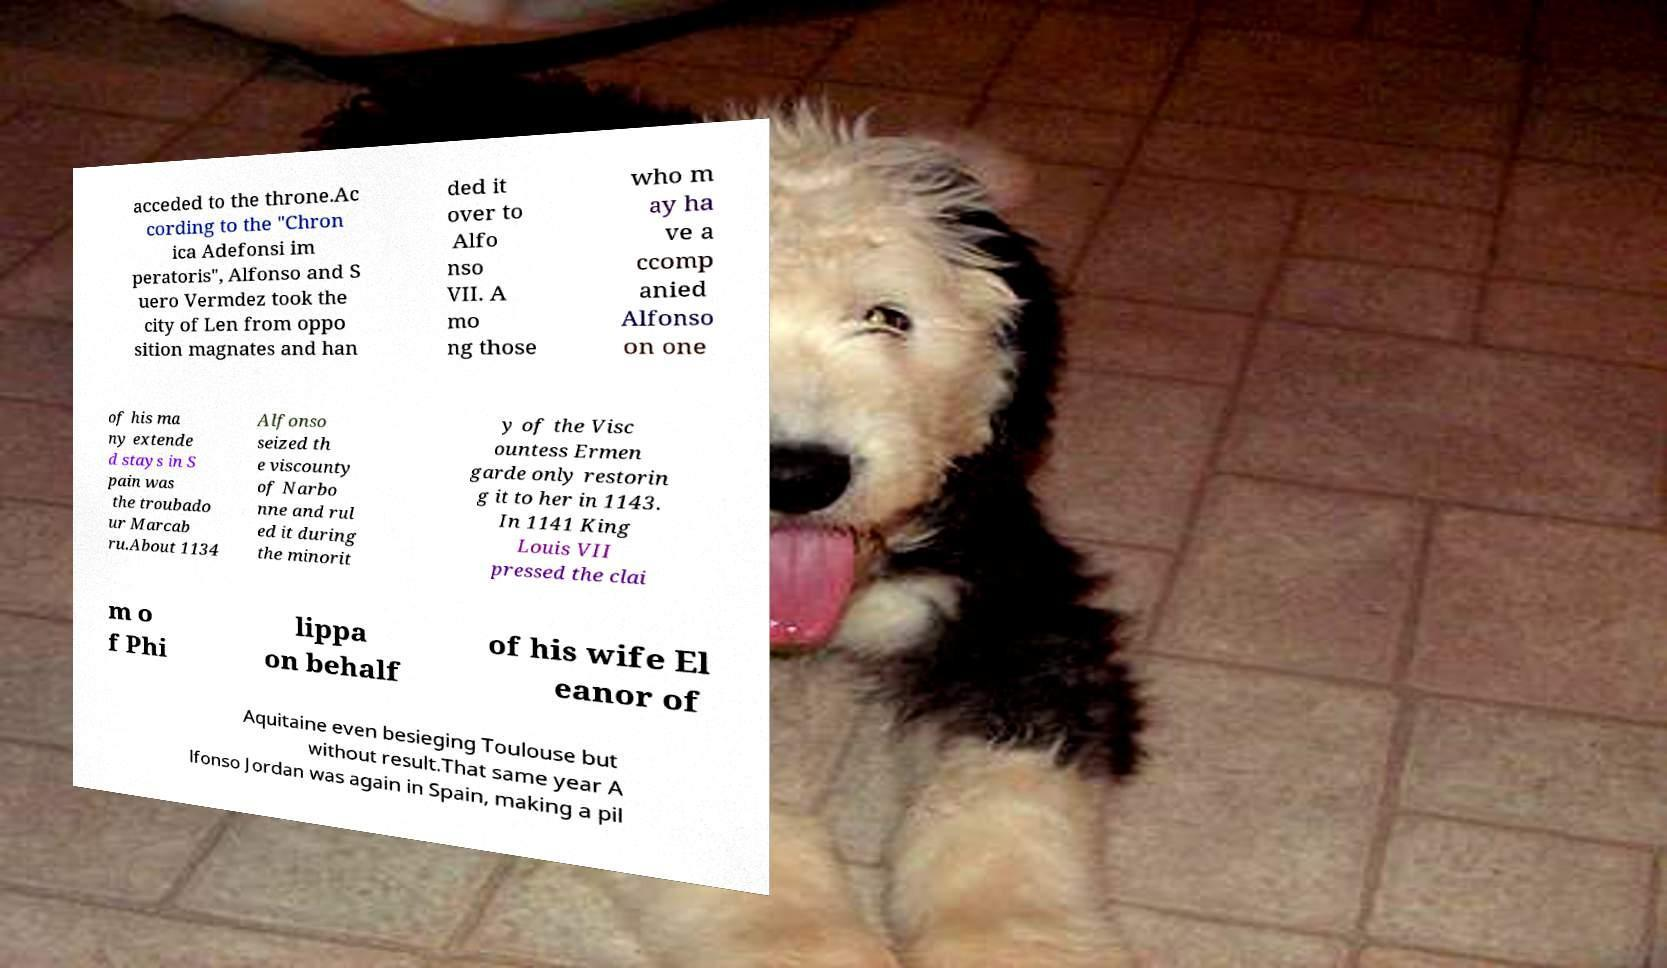There's text embedded in this image that I need extracted. Can you transcribe it verbatim? acceded to the throne.Ac cording to the "Chron ica Adefonsi im peratoris", Alfonso and S uero Vermdez took the city of Len from oppo sition magnates and han ded it over to Alfo nso VII. A mo ng those who m ay ha ve a ccomp anied Alfonso on one of his ma ny extende d stays in S pain was the troubado ur Marcab ru.About 1134 Alfonso seized th e viscounty of Narbo nne and rul ed it during the minorit y of the Visc ountess Ermen garde only restorin g it to her in 1143. In 1141 King Louis VII pressed the clai m o f Phi lippa on behalf of his wife El eanor of Aquitaine even besieging Toulouse but without result.That same year A lfonso Jordan was again in Spain, making a pil 